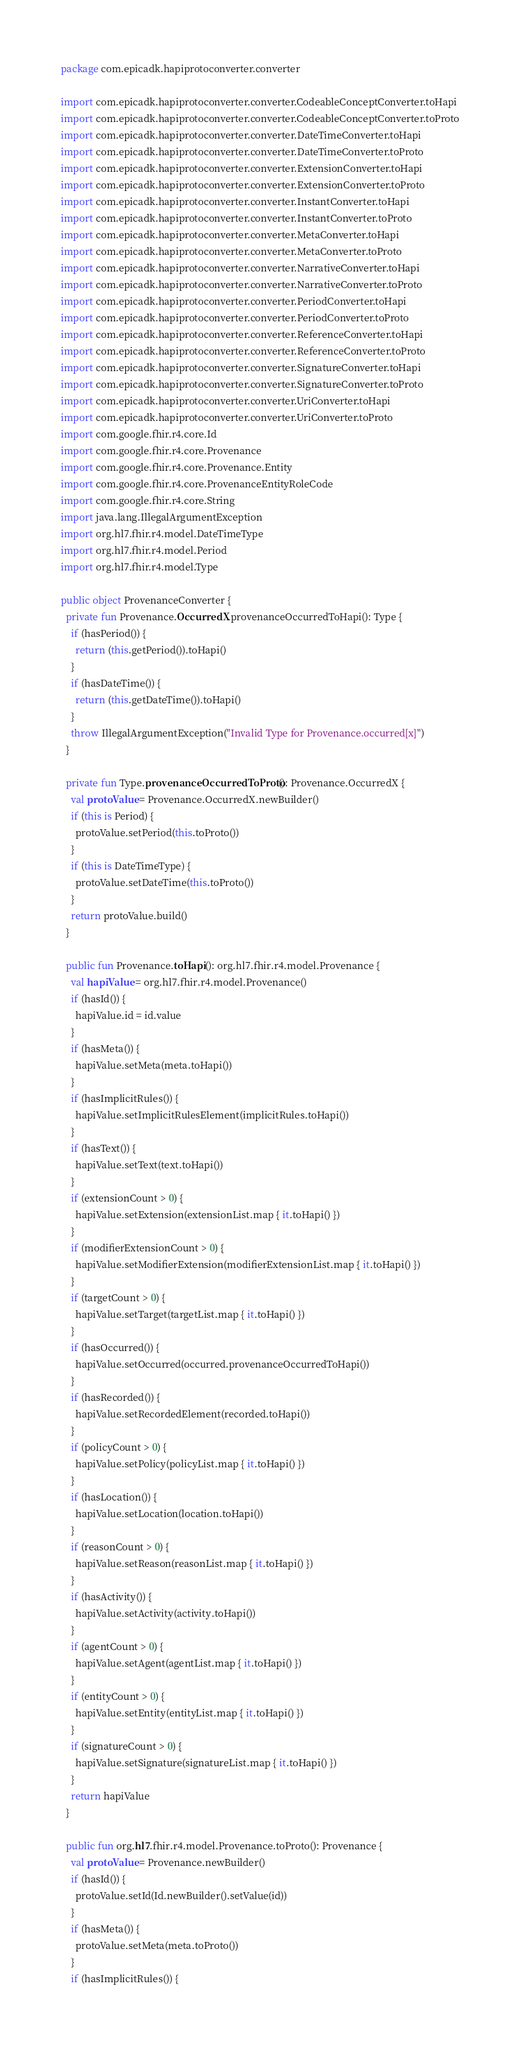<code> <loc_0><loc_0><loc_500><loc_500><_Kotlin_>package com.epicadk.hapiprotoconverter.converter

import com.epicadk.hapiprotoconverter.converter.CodeableConceptConverter.toHapi
import com.epicadk.hapiprotoconverter.converter.CodeableConceptConverter.toProto
import com.epicadk.hapiprotoconverter.converter.DateTimeConverter.toHapi
import com.epicadk.hapiprotoconverter.converter.DateTimeConverter.toProto
import com.epicadk.hapiprotoconverter.converter.ExtensionConverter.toHapi
import com.epicadk.hapiprotoconverter.converter.ExtensionConverter.toProto
import com.epicadk.hapiprotoconverter.converter.InstantConverter.toHapi
import com.epicadk.hapiprotoconverter.converter.InstantConverter.toProto
import com.epicadk.hapiprotoconverter.converter.MetaConverter.toHapi
import com.epicadk.hapiprotoconverter.converter.MetaConverter.toProto
import com.epicadk.hapiprotoconverter.converter.NarrativeConverter.toHapi
import com.epicadk.hapiprotoconverter.converter.NarrativeConverter.toProto
import com.epicadk.hapiprotoconverter.converter.PeriodConverter.toHapi
import com.epicadk.hapiprotoconverter.converter.PeriodConverter.toProto
import com.epicadk.hapiprotoconverter.converter.ReferenceConverter.toHapi
import com.epicadk.hapiprotoconverter.converter.ReferenceConverter.toProto
import com.epicadk.hapiprotoconverter.converter.SignatureConverter.toHapi
import com.epicadk.hapiprotoconverter.converter.SignatureConverter.toProto
import com.epicadk.hapiprotoconverter.converter.UriConverter.toHapi
import com.epicadk.hapiprotoconverter.converter.UriConverter.toProto
import com.google.fhir.r4.core.Id
import com.google.fhir.r4.core.Provenance
import com.google.fhir.r4.core.Provenance.Entity
import com.google.fhir.r4.core.ProvenanceEntityRoleCode
import com.google.fhir.r4.core.String
import java.lang.IllegalArgumentException
import org.hl7.fhir.r4.model.DateTimeType
import org.hl7.fhir.r4.model.Period
import org.hl7.fhir.r4.model.Type

public object ProvenanceConverter {
  private fun Provenance.OccurredX.provenanceOccurredToHapi(): Type {
    if (hasPeriod()) {
      return (this.getPeriod()).toHapi()
    }
    if (hasDateTime()) {
      return (this.getDateTime()).toHapi()
    }
    throw IllegalArgumentException("Invalid Type for Provenance.occurred[x]")
  }

  private fun Type.provenanceOccurredToProto(): Provenance.OccurredX {
    val protoValue = Provenance.OccurredX.newBuilder()
    if (this is Period) {
      protoValue.setPeriod(this.toProto())
    }
    if (this is DateTimeType) {
      protoValue.setDateTime(this.toProto())
    }
    return protoValue.build()
  }

  public fun Provenance.toHapi(): org.hl7.fhir.r4.model.Provenance {
    val hapiValue = org.hl7.fhir.r4.model.Provenance()
    if (hasId()) {
      hapiValue.id = id.value
    }
    if (hasMeta()) {
      hapiValue.setMeta(meta.toHapi())
    }
    if (hasImplicitRules()) {
      hapiValue.setImplicitRulesElement(implicitRules.toHapi())
    }
    if (hasText()) {
      hapiValue.setText(text.toHapi())
    }
    if (extensionCount > 0) {
      hapiValue.setExtension(extensionList.map { it.toHapi() })
    }
    if (modifierExtensionCount > 0) {
      hapiValue.setModifierExtension(modifierExtensionList.map { it.toHapi() })
    }
    if (targetCount > 0) {
      hapiValue.setTarget(targetList.map { it.toHapi() })
    }
    if (hasOccurred()) {
      hapiValue.setOccurred(occurred.provenanceOccurredToHapi())
    }
    if (hasRecorded()) {
      hapiValue.setRecordedElement(recorded.toHapi())
    }
    if (policyCount > 0) {
      hapiValue.setPolicy(policyList.map { it.toHapi() })
    }
    if (hasLocation()) {
      hapiValue.setLocation(location.toHapi())
    }
    if (reasonCount > 0) {
      hapiValue.setReason(reasonList.map { it.toHapi() })
    }
    if (hasActivity()) {
      hapiValue.setActivity(activity.toHapi())
    }
    if (agentCount > 0) {
      hapiValue.setAgent(agentList.map { it.toHapi() })
    }
    if (entityCount > 0) {
      hapiValue.setEntity(entityList.map { it.toHapi() })
    }
    if (signatureCount > 0) {
      hapiValue.setSignature(signatureList.map { it.toHapi() })
    }
    return hapiValue
  }

  public fun org.hl7.fhir.r4.model.Provenance.toProto(): Provenance {
    val protoValue = Provenance.newBuilder()
    if (hasId()) {
      protoValue.setId(Id.newBuilder().setValue(id))
    }
    if (hasMeta()) {
      protoValue.setMeta(meta.toProto())
    }
    if (hasImplicitRules()) {</code> 